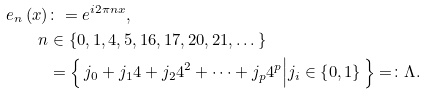Convert formula to latex. <formula><loc_0><loc_0><loc_500><loc_500>e _ { n } \left ( x \right ) & \colon = e ^ { i 2 \pi n x } , \\ n & \in \left \{ 0 , 1 , 4 , 5 , 1 6 , 1 7 , 2 0 , 2 1 , \dots \right \} \\ & = \left \{ \, j _ { 0 } + j _ { 1 } 4 + j _ { 2 } 4 ^ { 2 } + \dots + j _ { p } 4 ^ { p } \Big | j _ { i } \in \left \{ 0 , 1 \right \} \, \right \} = \colon \Lambda .</formula> 